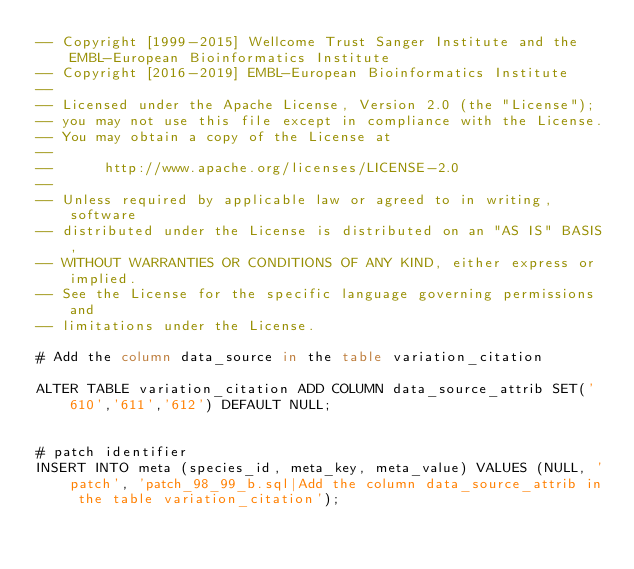Convert code to text. <code><loc_0><loc_0><loc_500><loc_500><_SQL_>-- Copyright [1999-2015] Wellcome Trust Sanger Institute and the EMBL-European Bioinformatics Institute
-- Copyright [2016-2019] EMBL-European Bioinformatics Institute
-- 
-- Licensed under the Apache License, Version 2.0 (the "License");
-- you may not use this file except in compliance with the License.
-- You may obtain a copy of the License at
-- 
--      http://www.apache.org/licenses/LICENSE-2.0
-- 
-- Unless required by applicable law or agreed to in writing, software
-- distributed under the License is distributed on an "AS IS" BASIS,
-- WITHOUT WARRANTIES OR CONDITIONS OF ANY KIND, either express or implied.
-- See the License for the specific language governing permissions and
-- limitations under the License.

# Add the column data_source in the table variation_citation  

ALTER TABLE variation_citation ADD COLUMN data_source_attrib SET('610','611','612') DEFAULT NULL; 


# patch identifier
INSERT INTO meta (species_id, meta_key, meta_value) VALUES (NULL, 'patch', 'patch_98_99_b.sql|Add the column data_source_attrib in the table variation_citation');
</code> 